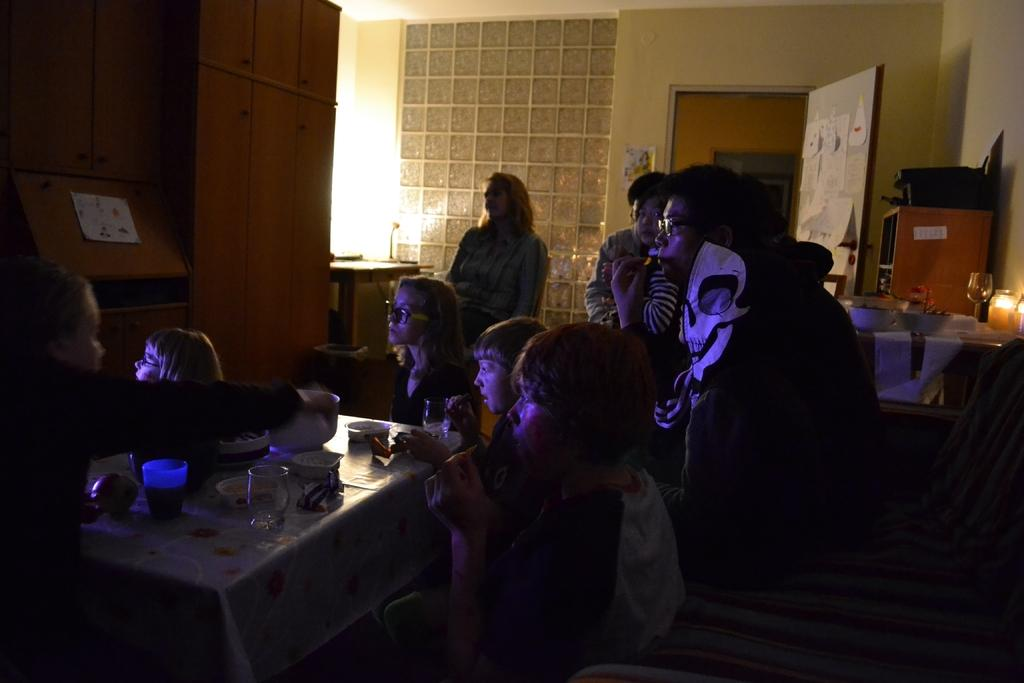What are the people in the image doing? The people in the image are sitting on chairs. What objects can be seen on the table in the image? There are glasses on the table in the image. Can you describe the people in the background of the image? There are other people standing in the background of the image. What type of error can be seen on the mask in the image? There is no mask present in the image, so it is not possible to determine if there is an error on it. 